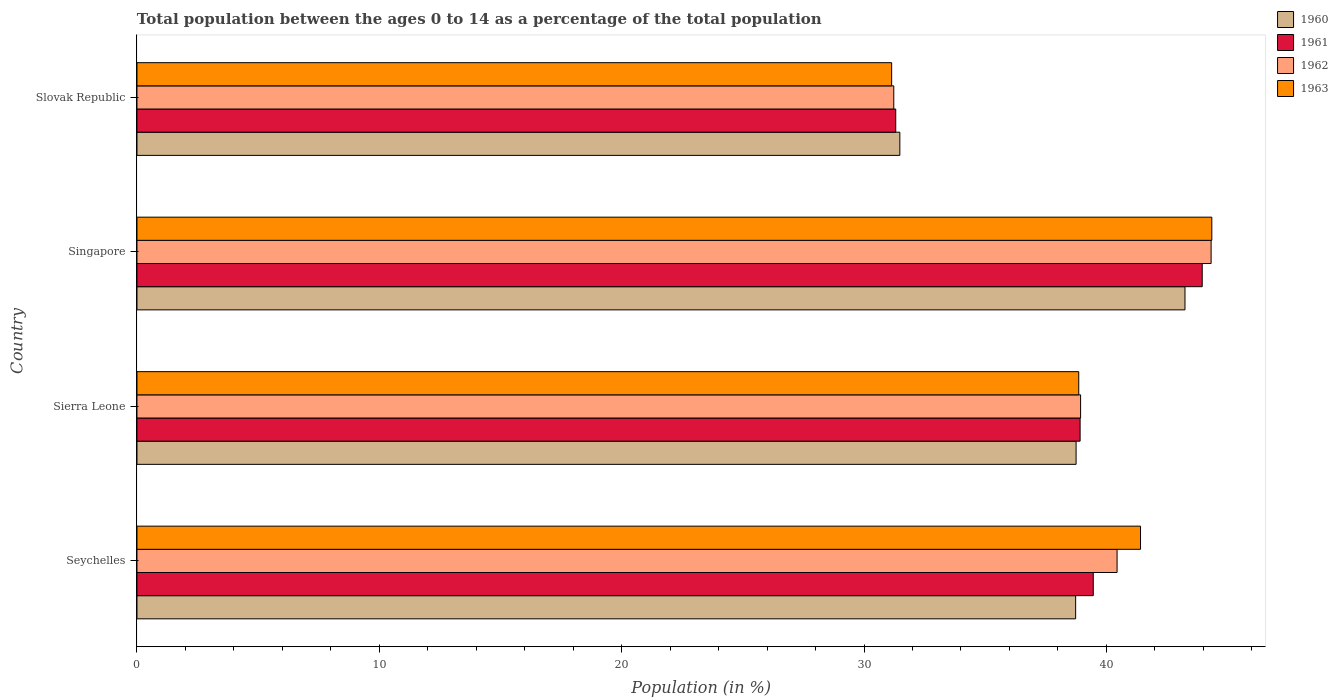How many groups of bars are there?
Ensure brevity in your answer.  4. Are the number of bars per tick equal to the number of legend labels?
Provide a succinct answer. Yes. Are the number of bars on each tick of the Y-axis equal?
Provide a short and direct response. Yes. How many bars are there on the 2nd tick from the bottom?
Make the answer very short. 4. What is the label of the 2nd group of bars from the top?
Offer a terse response. Singapore. In how many cases, is the number of bars for a given country not equal to the number of legend labels?
Provide a succinct answer. 0. What is the percentage of the population ages 0 to 14 in 1963 in Slovak Republic?
Offer a very short reply. 31.14. Across all countries, what is the maximum percentage of the population ages 0 to 14 in 1960?
Offer a terse response. 43.25. Across all countries, what is the minimum percentage of the population ages 0 to 14 in 1961?
Your answer should be compact. 31.31. In which country was the percentage of the population ages 0 to 14 in 1960 maximum?
Make the answer very short. Singapore. In which country was the percentage of the population ages 0 to 14 in 1960 minimum?
Provide a succinct answer. Slovak Republic. What is the total percentage of the population ages 0 to 14 in 1963 in the graph?
Your answer should be very brief. 155.77. What is the difference between the percentage of the population ages 0 to 14 in 1962 in Seychelles and that in Slovak Republic?
Give a very brief answer. 9.21. What is the difference between the percentage of the population ages 0 to 14 in 1960 in Singapore and the percentage of the population ages 0 to 14 in 1962 in Slovak Republic?
Keep it short and to the point. 12.02. What is the average percentage of the population ages 0 to 14 in 1961 per country?
Your answer should be compact. 38.41. What is the difference between the percentage of the population ages 0 to 14 in 1963 and percentage of the population ages 0 to 14 in 1960 in Seychelles?
Provide a short and direct response. 2.68. In how many countries, is the percentage of the population ages 0 to 14 in 1961 greater than 6 ?
Make the answer very short. 4. What is the ratio of the percentage of the population ages 0 to 14 in 1963 in Seychelles to that in Singapore?
Your answer should be very brief. 0.93. Is the difference between the percentage of the population ages 0 to 14 in 1963 in Seychelles and Sierra Leone greater than the difference between the percentage of the population ages 0 to 14 in 1960 in Seychelles and Sierra Leone?
Offer a very short reply. Yes. What is the difference between the highest and the second highest percentage of the population ages 0 to 14 in 1961?
Provide a short and direct response. 4.5. What is the difference between the highest and the lowest percentage of the population ages 0 to 14 in 1961?
Provide a succinct answer. 12.65. Is the sum of the percentage of the population ages 0 to 14 in 1962 in Sierra Leone and Singapore greater than the maximum percentage of the population ages 0 to 14 in 1963 across all countries?
Provide a short and direct response. Yes. What does the 1st bar from the top in Sierra Leone represents?
Give a very brief answer. 1963. What does the 1st bar from the bottom in Seychelles represents?
Ensure brevity in your answer.  1960. Is it the case that in every country, the sum of the percentage of the population ages 0 to 14 in 1962 and percentage of the population ages 0 to 14 in 1961 is greater than the percentage of the population ages 0 to 14 in 1963?
Your answer should be compact. Yes. How many bars are there?
Give a very brief answer. 16. Are all the bars in the graph horizontal?
Offer a terse response. Yes. Are the values on the major ticks of X-axis written in scientific E-notation?
Give a very brief answer. No. Does the graph contain any zero values?
Your answer should be compact. No. How many legend labels are there?
Keep it short and to the point. 4. What is the title of the graph?
Offer a very short reply. Total population between the ages 0 to 14 as a percentage of the total population. Does "2010" appear as one of the legend labels in the graph?
Offer a very short reply. No. What is the label or title of the X-axis?
Make the answer very short. Population (in %). What is the label or title of the Y-axis?
Offer a very short reply. Country. What is the Population (in %) in 1960 in Seychelles?
Offer a terse response. 38.73. What is the Population (in %) of 1961 in Seychelles?
Offer a terse response. 39.46. What is the Population (in %) of 1962 in Seychelles?
Keep it short and to the point. 40.44. What is the Population (in %) of 1963 in Seychelles?
Your answer should be compact. 41.41. What is the Population (in %) in 1960 in Sierra Leone?
Your answer should be very brief. 38.75. What is the Population (in %) in 1961 in Sierra Leone?
Make the answer very short. 38.92. What is the Population (in %) of 1962 in Sierra Leone?
Offer a very short reply. 38.94. What is the Population (in %) of 1963 in Sierra Leone?
Make the answer very short. 38.86. What is the Population (in %) in 1960 in Singapore?
Provide a succinct answer. 43.25. What is the Population (in %) of 1961 in Singapore?
Ensure brevity in your answer.  43.96. What is the Population (in %) in 1962 in Singapore?
Your answer should be very brief. 44.32. What is the Population (in %) in 1963 in Singapore?
Provide a succinct answer. 44.35. What is the Population (in %) in 1960 in Slovak Republic?
Give a very brief answer. 31.48. What is the Population (in %) in 1961 in Slovak Republic?
Your answer should be very brief. 31.31. What is the Population (in %) of 1962 in Slovak Republic?
Make the answer very short. 31.23. What is the Population (in %) of 1963 in Slovak Republic?
Offer a very short reply. 31.14. Across all countries, what is the maximum Population (in %) of 1960?
Provide a short and direct response. 43.25. Across all countries, what is the maximum Population (in %) in 1961?
Your answer should be very brief. 43.96. Across all countries, what is the maximum Population (in %) of 1962?
Keep it short and to the point. 44.32. Across all countries, what is the maximum Population (in %) of 1963?
Your answer should be very brief. 44.35. Across all countries, what is the minimum Population (in %) in 1960?
Ensure brevity in your answer.  31.48. Across all countries, what is the minimum Population (in %) of 1961?
Keep it short and to the point. 31.31. Across all countries, what is the minimum Population (in %) of 1962?
Your answer should be very brief. 31.23. Across all countries, what is the minimum Population (in %) in 1963?
Provide a succinct answer. 31.14. What is the total Population (in %) in 1960 in the graph?
Offer a terse response. 152.21. What is the total Population (in %) in 1961 in the graph?
Your answer should be compact. 153.64. What is the total Population (in %) in 1962 in the graph?
Give a very brief answer. 154.93. What is the total Population (in %) in 1963 in the graph?
Provide a succinct answer. 155.77. What is the difference between the Population (in %) in 1960 in Seychelles and that in Sierra Leone?
Make the answer very short. -0.02. What is the difference between the Population (in %) in 1961 in Seychelles and that in Sierra Leone?
Provide a short and direct response. 0.54. What is the difference between the Population (in %) in 1962 in Seychelles and that in Sierra Leone?
Your answer should be very brief. 1.51. What is the difference between the Population (in %) in 1963 in Seychelles and that in Sierra Leone?
Provide a short and direct response. 2.55. What is the difference between the Population (in %) in 1960 in Seychelles and that in Singapore?
Your response must be concise. -4.51. What is the difference between the Population (in %) of 1961 in Seychelles and that in Singapore?
Your answer should be compact. -4.5. What is the difference between the Population (in %) in 1962 in Seychelles and that in Singapore?
Your answer should be very brief. -3.88. What is the difference between the Population (in %) of 1963 in Seychelles and that in Singapore?
Your answer should be very brief. -2.94. What is the difference between the Population (in %) in 1960 in Seychelles and that in Slovak Republic?
Offer a very short reply. 7.25. What is the difference between the Population (in %) of 1961 in Seychelles and that in Slovak Republic?
Offer a terse response. 8.15. What is the difference between the Population (in %) in 1962 in Seychelles and that in Slovak Republic?
Provide a succinct answer. 9.21. What is the difference between the Population (in %) of 1963 in Seychelles and that in Slovak Republic?
Offer a very short reply. 10.27. What is the difference between the Population (in %) of 1960 in Sierra Leone and that in Singapore?
Offer a very short reply. -4.49. What is the difference between the Population (in %) in 1961 in Sierra Leone and that in Singapore?
Keep it short and to the point. -5.04. What is the difference between the Population (in %) in 1962 in Sierra Leone and that in Singapore?
Keep it short and to the point. -5.39. What is the difference between the Population (in %) in 1963 in Sierra Leone and that in Singapore?
Give a very brief answer. -5.49. What is the difference between the Population (in %) of 1960 in Sierra Leone and that in Slovak Republic?
Your answer should be compact. 7.27. What is the difference between the Population (in %) in 1961 in Sierra Leone and that in Slovak Republic?
Your answer should be very brief. 7.61. What is the difference between the Population (in %) in 1962 in Sierra Leone and that in Slovak Republic?
Ensure brevity in your answer.  7.71. What is the difference between the Population (in %) of 1963 in Sierra Leone and that in Slovak Republic?
Your answer should be very brief. 7.72. What is the difference between the Population (in %) in 1960 in Singapore and that in Slovak Republic?
Keep it short and to the point. 11.77. What is the difference between the Population (in %) of 1961 in Singapore and that in Slovak Republic?
Your answer should be compact. 12.65. What is the difference between the Population (in %) in 1962 in Singapore and that in Slovak Republic?
Offer a terse response. 13.09. What is the difference between the Population (in %) in 1963 in Singapore and that in Slovak Republic?
Ensure brevity in your answer.  13.21. What is the difference between the Population (in %) in 1960 in Seychelles and the Population (in %) in 1961 in Sierra Leone?
Ensure brevity in your answer.  -0.18. What is the difference between the Population (in %) in 1960 in Seychelles and the Population (in %) in 1962 in Sierra Leone?
Ensure brevity in your answer.  -0.2. What is the difference between the Population (in %) of 1960 in Seychelles and the Population (in %) of 1963 in Sierra Leone?
Offer a very short reply. -0.13. What is the difference between the Population (in %) in 1961 in Seychelles and the Population (in %) in 1962 in Sierra Leone?
Ensure brevity in your answer.  0.52. What is the difference between the Population (in %) in 1961 in Seychelles and the Population (in %) in 1963 in Sierra Leone?
Your answer should be very brief. 0.6. What is the difference between the Population (in %) of 1962 in Seychelles and the Population (in %) of 1963 in Sierra Leone?
Your answer should be very brief. 1.58. What is the difference between the Population (in %) of 1960 in Seychelles and the Population (in %) of 1961 in Singapore?
Your response must be concise. -5.22. What is the difference between the Population (in %) of 1960 in Seychelles and the Population (in %) of 1962 in Singapore?
Give a very brief answer. -5.59. What is the difference between the Population (in %) in 1960 in Seychelles and the Population (in %) in 1963 in Singapore?
Provide a succinct answer. -5.62. What is the difference between the Population (in %) of 1961 in Seychelles and the Population (in %) of 1962 in Singapore?
Offer a terse response. -4.86. What is the difference between the Population (in %) of 1961 in Seychelles and the Population (in %) of 1963 in Singapore?
Your answer should be very brief. -4.89. What is the difference between the Population (in %) of 1962 in Seychelles and the Population (in %) of 1963 in Singapore?
Offer a very short reply. -3.91. What is the difference between the Population (in %) in 1960 in Seychelles and the Population (in %) in 1961 in Slovak Republic?
Make the answer very short. 7.42. What is the difference between the Population (in %) of 1960 in Seychelles and the Population (in %) of 1962 in Slovak Republic?
Provide a short and direct response. 7.5. What is the difference between the Population (in %) of 1960 in Seychelles and the Population (in %) of 1963 in Slovak Republic?
Keep it short and to the point. 7.59. What is the difference between the Population (in %) of 1961 in Seychelles and the Population (in %) of 1962 in Slovak Republic?
Your answer should be very brief. 8.23. What is the difference between the Population (in %) in 1961 in Seychelles and the Population (in %) in 1963 in Slovak Republic?
Your answer should be compact. 8.32. What is the difference between the Population (in %) of 1962 in Seychelles and the Population (in %) of 1963 in Slovak Republic?
Offer a very short reply. 9.3. What is the difference between the Population (in %) of 1960 in Sierra Leone and the Population (in %) of 1961 in Singapore?
Provide a short and direct response. -5.2. What is the difference between the Population (in %) of 1960 in Sierra Leone and the Population (in %) of 1962 in Singapore?
Your answer should be very brief. -5.57. What is the difference between the Population (in %) in 1960 in Sierra Leone and the Population (in %) in 1963 in Singapore?
Ensure brevity in your answer.  -5.6. What is the difference between the Population (in %) in 1961 in Sierra Leone and the Population (in %) in 1962 in Singapore?
Your answer should be compact. -5.41. What is the difference between the Population (in %) in 1961 in Sierra Leone and the Population (in %) in 1963 in Singapore?
Ensure brevity in your answer.  -5.43. What is the difference between the Population (in %) of 1962 in Sierra Leone and the Population (in %) of 1963 in Singapore?
Offer a very short reply. -5.41. What is the difference between the Population (in %) of 1960 in Sierra Leone and the Population (in %) of 1961 in Slovak Republic?
Make the answer very short. 7.44. What is the difference between the Population (in %) of 1960 in Sierra Leone and the Population (in %) of 1962 in Slovak Republic?
Give a very brief answer. 7.52. What is the difference between the Population (in %) of 1960 in Sierra Leone and the Population (in %) of 1963 in Slovak Republic?
Your response must be concise. 7.61. What is the difference between the Population (in %) in 1961 in Sierra Leone and the Population (in %) in 1962 in Slovak Republic?
Offer a very short reply. 7.69. What is the difference between the Population (in %) of 1961 in Sierra Leone and the Population (in %) of 1963 in Slovak Republic?
Provide a succinct answer. 7.78. What is the difference between the Population (in %) of 1962 in Sierra Leone and the Population (in %) of 1963 in Slovak Republic?
Your response must be concise. 7.8. What is the difference between the Population (in %) in 1960 in Singapore and the Population (in %) in 1961 in Slovak Republic?
Your response must be concise. 11.94. What is the difference between the Population (in %) of 1960 in Singapore and the Population (in %) of 1962 in Slovak Republic?
Your response must be concise. 12.02. What is the difference between the Population (in %) of 1960 in Singapore and the Population (in %) of 1963 in Slovak Republic?
Your response must be concise. 12.1. What is the difference between the Population (in %) in 1961 in Singapore and the Population (in %) in 1962 in Slovak Republic?
Your response must be concise. 12.73. What is the difference between the Population (in %) in 1961 in Singapore and the Population (in %) in 1963 in Slovak Republic?
Provide a short and direct response. 12.82. What is the difference between the Population (in %) in 1962 in Singapore and the Population (in %) in 1963 in Slovak Republic?
Ensure brevity in your answer.  13.18. What is the average Population (in %) of 1960 per country?
Ensure brevity in your answer.  38.05. What is the average Population (in %) of 1961 per country?
Provide a short and direct response. 38.41. What is the average Population (in %) in 1962 per country?
Provide a short and direct response. 38.73. What is the average Population (in %) of 1963 per country?
Your answer should be compact. 38.94. What is the difference between the Population (in %) in 1960 and Population (in %) in 1961 in Seychelles?
Your answer should be very brief. -0.73. What is the difference between the Population (in %) of 1960 and Population (in %) of 1962 in Seychelles?
Keep it short and to the point. -1.71. What is the difference between the Population (in %) in 1960 and Population (in %) in 1963 in Seychelles?
Your answer should be very brief. -2.68. What is the difference between the Population (in %) of 1961 and Population (in %) of 1962 in Seychelles?
Offer a terse response. -0.98. What is the difference between the Population (in %) in 1961 and Population (in %) in 1963 in Seychelles?
Offer a very short reply. -1.95. What is the difference between the Population (in %) in 1962 and Population (in %) in 1963 in Seychelles?
Ensure brevity in your answer.  -0.97. What is the difference between the Population (in %) of 1960 and Population (in %) of 1961 in Sierra Leone?
Your response must be concise. -0.17. What is the difference between the Population (in %) in 1960 and Population (in %) in 1962 in Sierra Leone?
Give a very brief answer. -0.19. What is the difference between the Population (in %) of 1960 and Population (in %) of 1963 in Sierra Leone?
Ensure brevity in your answer.  -0.11. What is the difference between the Population (in %) in 1961 and Population (in %) in 1962 in Sierra Leone?
Provide a succinct answer. -0.02. What is the difference between the Population (in %) in 1961 and Population (in %) in 1963 in Sierra Leone?
Offer a very short reply. 0.06. What is the difference between the Population (in %) in 1962 and Population (in %) in 1963 in Sierra Leone?
Keep it short and to the point. 0.08. What is the difference between the Population (in %) in 1960 and Population (in %) in 1961 in Singapore?
Keep it short and to the point. -0.71. What is the difference between the Population (in %) in 1960 and Population (in %) in 1962 in Singapore?
Ensure brevity in your answer.  -1.08. What is the difference between the Population (in %) in 1960 and Population (in %) in 1963 in Singapore?
Provide a short and direct response. -1.11. What is the difference between the Population (in %) of 1961 and Population (in %) of 1962 in Singapore?
Provide a short and direct response. -0.37. What is the difference between the Population (in %) in 1961 and Population (in %) in 1963 in Singapore?
Provide a succinct answer. -0.4. What is the difference between the Population (in %) in 1962 and Population (in %) in 1963 in Singapore?
Keep it short and to the point. -0.03. What is the difference between the Population (in %) in 1960 and Population (in %) in 1961 in Slovak Republic?
Ensure brevity in your answer.  0.17. What is the difference between the Population (in %) in 1960 and Population (in %) in 1962 in Slovak Republic?
Provide a succinct answer. 0.25. What is the difference between the Population (in %) in 1960 and Population (in %) in 1963 in Slovak Republic?
Ensure brevity in your answer.  0.34. What is the difference between the Population (in %) of 1961 and Population (in %) of 1962 in Slovak Republic?
Offer a very short reply. 0.08. What is the difference between the Population (in %) in 1961 and Population (in %) in 1963 in Slovak Republic?
Keep it short and to the point. 0.17. What is the difference between the Population (in %) of 1962 and Population (in %) of 1963 in Slovak Republic?
Provide a short and direct response. 0.09. What is the ratio of the Population (in %) of 1960 in Seychelles to that in Sierra Leone?
Offer a terse response. 1. What is the ratio of the Population (in %) of 1961 in Seychelles to that in Sierra Leone?
Your answer should be very brief. 1.01. What is the ratio of the Population (in %) in 1962 in Seychelles to that in Sierra Leone?
Keep it short and to the point. 1.04. What is the ratio of the Population (in %) in 1963 in Seychelles to that in Sierra Leone?
Give a very brief answer. 1.07. What is the ratio of the Population (in %) of 1960 in Seychelles to that in Singapore?
Offer a terse response. 0.9. What is the ratio of the Population (in %) of 1961 in Seychelles to that in Singapore?
Provide a short and direct response. 0.9. What is the ratio of the Population (in %) in 1962 in Seychelles to that in Singapore?
Offer a very short reply. 0.91. What is the ratio of the Population (in %) of 1963 in Seychelles to that in Singapore?
Give a very brief answer. 0.93. What is the ratio of the Population (in %) of 1960 in Seychelles to that in Slovak Republic?
Ensure brevity in your answer.  1.23. What is the ratio of the Population (in %) of 1961 in Seychelles to that in Slovak Republic?
Give a very brief answer. 1.26. What is the ratio of the Population (in %) in 1962 in Seychelles to that in Slovak Republic?
Keep it short and to the point. 1.3. What is the ratio of the Population (in %) in 1963 in Seychelles to that in Slovak Republic?
Offer a very short reply. 1.33. What is the ratio of the Population (in %) of 1960 in Sierra Leone to that in Singapore?
Make the answer very short. 0.9. What is the ratio of the Population (in %) in 1961 in Sierra Leone to that in Singapore?
Give a very brief answer. 0.89. What is the ratio of the Population (in %) of 1962 in Sierra Leone to that in Singapore?
Provide a short and direct response. 0.88. What is the ratio of the Population (in %) in 1963 in Sierra Leone to that in Singapore?
Offer a very short reply. 0.88. What is the ratio of the Population (in %) in 1960 in Sierra Leone to that in Slovak Republic?
Give a very brief answer. 1.23. What is the ratio of the Population (in %) in 1961 in Sierra Leone to that in Slovak Republic?
Your answer should be very brief. 1.24. What is the ratio of the Population (in %) in 1962 in Sierra Leone to that in Slovak Republic?
Make the answer very short. 1.25. What is the ratio of the Population (in %) in 1963 in Sierra Leone to that in Slovak Republic?
Your answer should be compact. 1.25. What is the ratio of the Population (in %) of 1960 in Singapore to that in Slovak Republic?
Give a very brief answer. 1.37. What is the ratio of the Population (in %) of 1961 in Singapore to that in Slovak Republic?
Provide a short and direct response. 1.4. What is the ratio of the Population (in %) in 1962 in Singapore to that in Slovak Republic?
Your response must be concise. 1.42. What is the ratio of the Population (in %) of 1963 in Singapore to that in Slovak Republic?
Make the answer very short. 1.42. What is the difference between the highest and the second highest Population (in %) in 1960?
Offer a very short reply. 4.49. What is the difference between the highest and the second highest Population (in %) of 1961?
Your answer should be very brief. 4.5. What is the difference between the highest and the second highest Population (in %) of 1962?
Offer a very short reply. 3.88. What is the difference between the highest and the second highest Population (in %) in 1963?
Provide a succinct answer. 2.94. What is the difference between the highest and the lowest Population (in %) in 1960?
Ensure brevity in your answer.  11.77. What is the difference between the highest and the lowest Population (in %) of 1961?
Provide a short and direct response. 12.65. What is the difference between the highest and the lowest Population (in %) in 1962?
Give a very brief answer. 13.09. What is the difference between the highest and the lowest Population (in %) in 1963?
Keep it short and to the point. 13.21. 